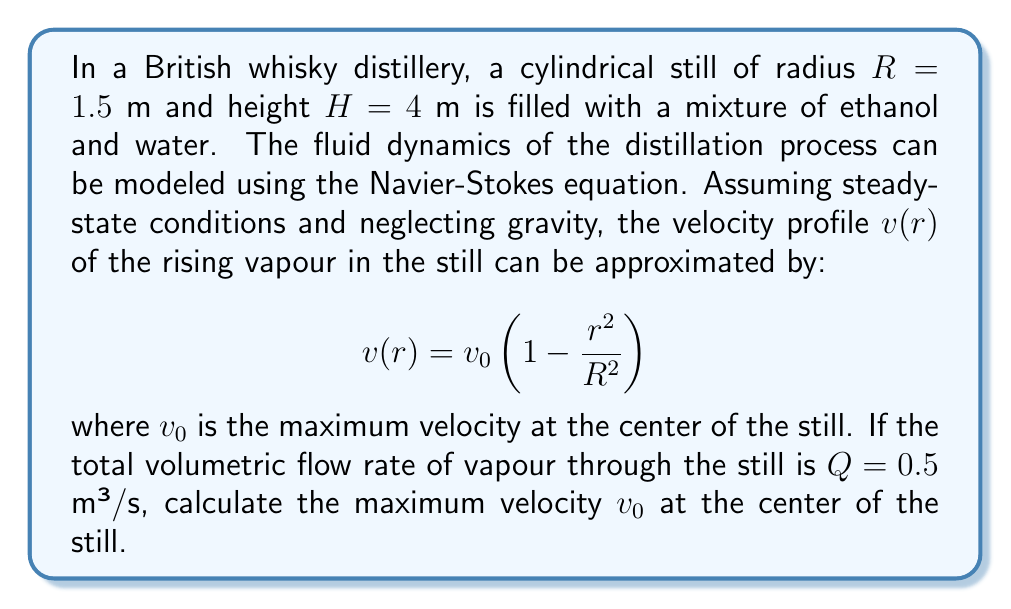Can you solve this math problem? To solve this problem, we'll follow these steps:

1) The volumetric flow rate $Q$ is equal to the integral of the velocity profile over the cross-sectional area of the still.

2) We can express this mathematically as:

   $$Q = \int_0^R 2\pi r v(r) dr$$

3) Substituting the given velocity profile:

   $$Q = \int_0^R 2\pi r v_0 \left(1 - \frac{r^2}{R^2}\right) dr$$

4) Expanding the integrand:

   $$Q = 2\pi v_0 \int_0^R \left(r - \frac{r^3}{R^2}\right) dr$$

5) Integrating:

   $$Q = 2\pi v_0 \left[\frac{r^2}{2} - \frac{r^4}{4R^2}\right]_0^R$$

6) Evaluating the definite integral:

   $$Q = 2\pi v_0 \left[\frac{R^2}{2} - \frac{R^4}{4R^2}\right] = 2\pi v_0 \left[\frac{R^2}{2} - \frac{R^2}{4}\right] = \frac{\pi R^2 v_0}{2}$$

7) Rearranging to solve for $v_0$:

   $$v_0 = \frac{2Q}{\pi R^2}$$

8) Substituting the given values:

   $$v_0 = \frac{2 \cdot 0.5}{\pi \cdot (1.5)^2} \approx 0.1415 \text{ m/s}$$

Therefore, the maximum velocity at the center of the still is approximately 0.1415 m/s.
Answer: $v_0 \approx 0.1415 \text{ m/s}$ 